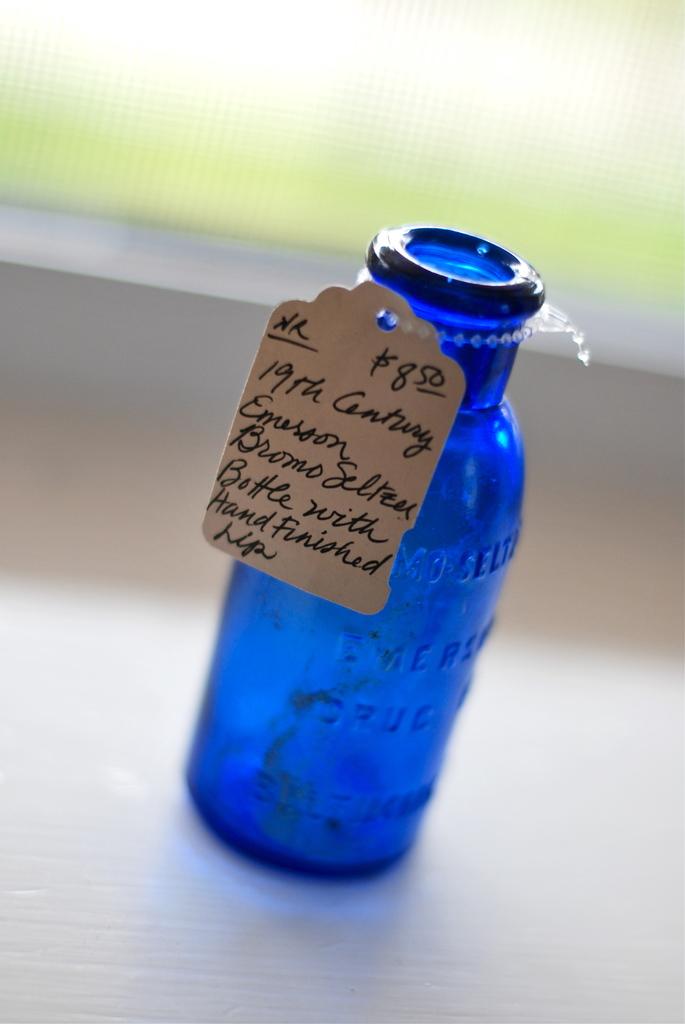How much does this cost?
Provide a succinct answer. 8.50. 